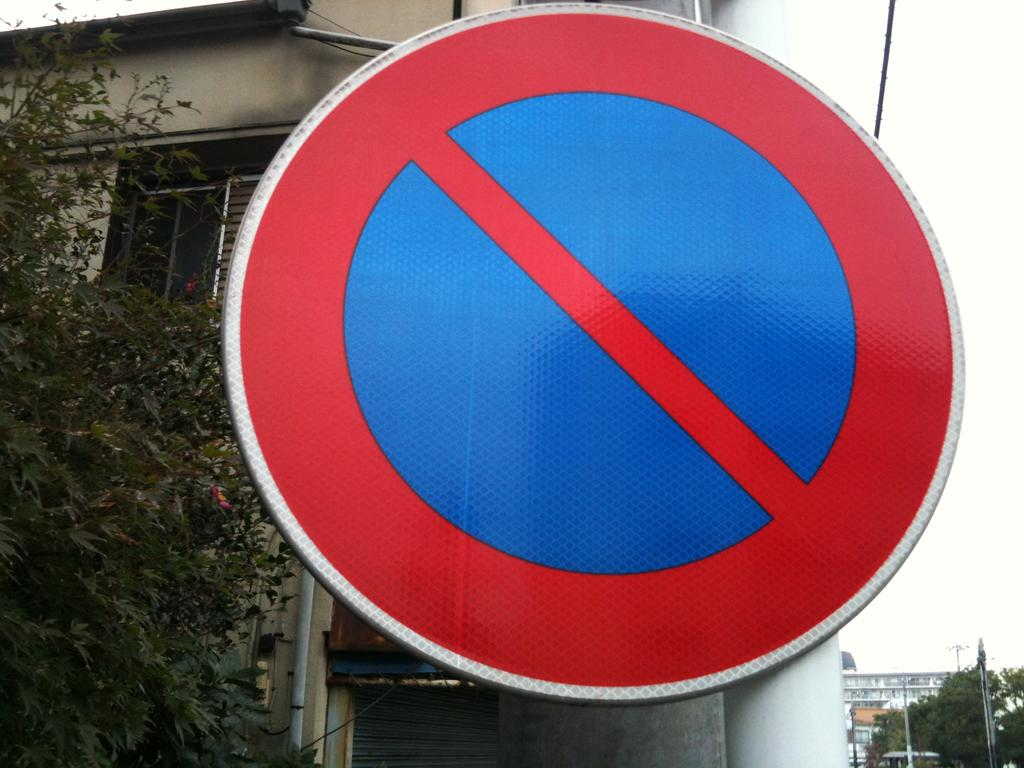What is the main object in the image? There is a sign board in the image. What else can be seen in the image besides the sign board? There are buildings, trees, and poles in the image. What is visible in the background of the image? The sky is visible in the image. How many mice are sitting on the sign board in the image? There are no mice present in the image. What type of question is being asked on the sign board in the image? There is no question visible on the sign board in the image. 